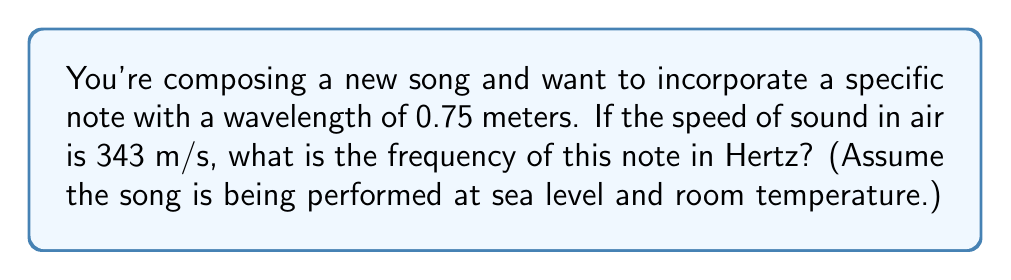Solve this math problem. To solve this problem, we'll use the relationship between wavelength, frequency, and speed of sound. The formula is:

$$v = f \lambda$$

Where:
$v$ = speed of sound (m/s)
$f$ = frequency (Hz)
$\lambda$ = wavelength (m)

We're given:
$v = 343$ m/s
$\lambda = 0.75$ m

Let's solve for $f$:

1) Rearrange the formula to isolate $f$:
   $$f = \frac{v}{\lambda}$$

2) Substitute the known values:
   $$f = \frac{343 \text{ m/s}}{0.75 \text{ m}}$$

3) Calculate:
   $$f = 457.33 \text{ Hz}$$

4) Round to the nearest whole number:
   $$f \approx 457 \text{ Hz}$$

Therefore, the frequency of the note is approximately 457 Hz.
Answer: 457 Hz 